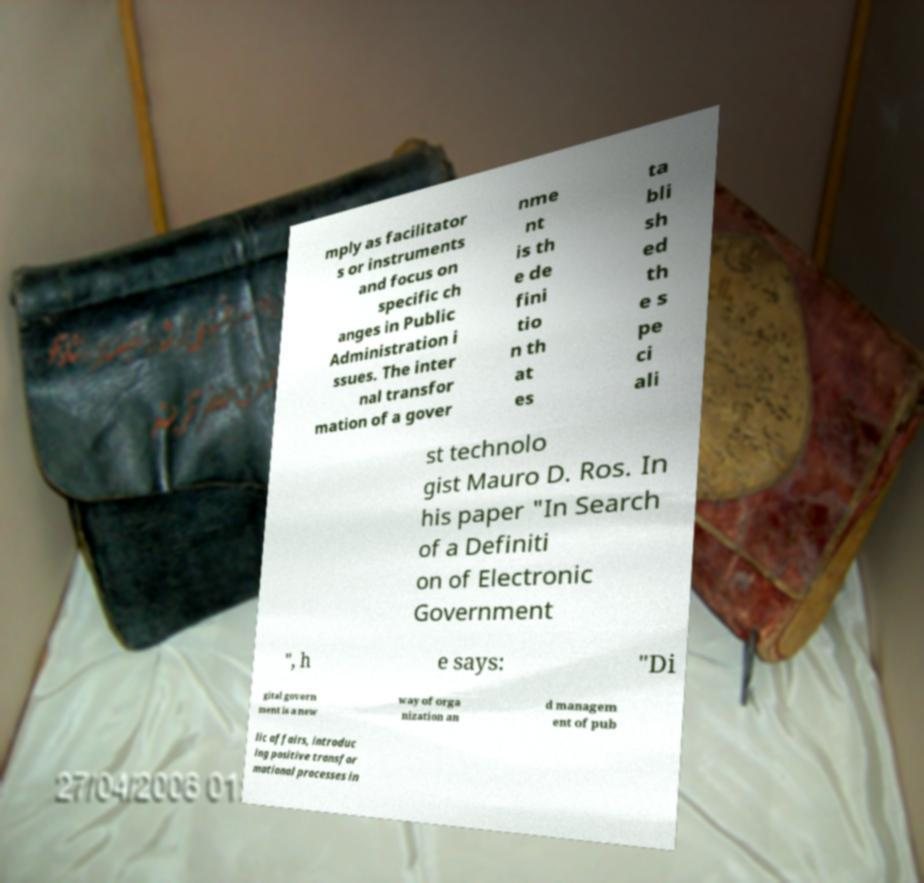For documentation purposes, I need the text within this image transcribed. Could you provide that? mply as facilitator s or instruments and focus on specific ch anges in Public Administration i ssues. The inter nal transfor mation of a gover nme nt is th e de fini tio n th at es ta bli sh ed th e s pe ci ali st technolo gist Mauro D. Ros. In his paper "In Search of a Definiti on of Electronic Government ", h e says: "Di gital govern ment is a new way of orga nization an d managem ent of pub lic affairs, introduc ing positive transfor mational processes in 